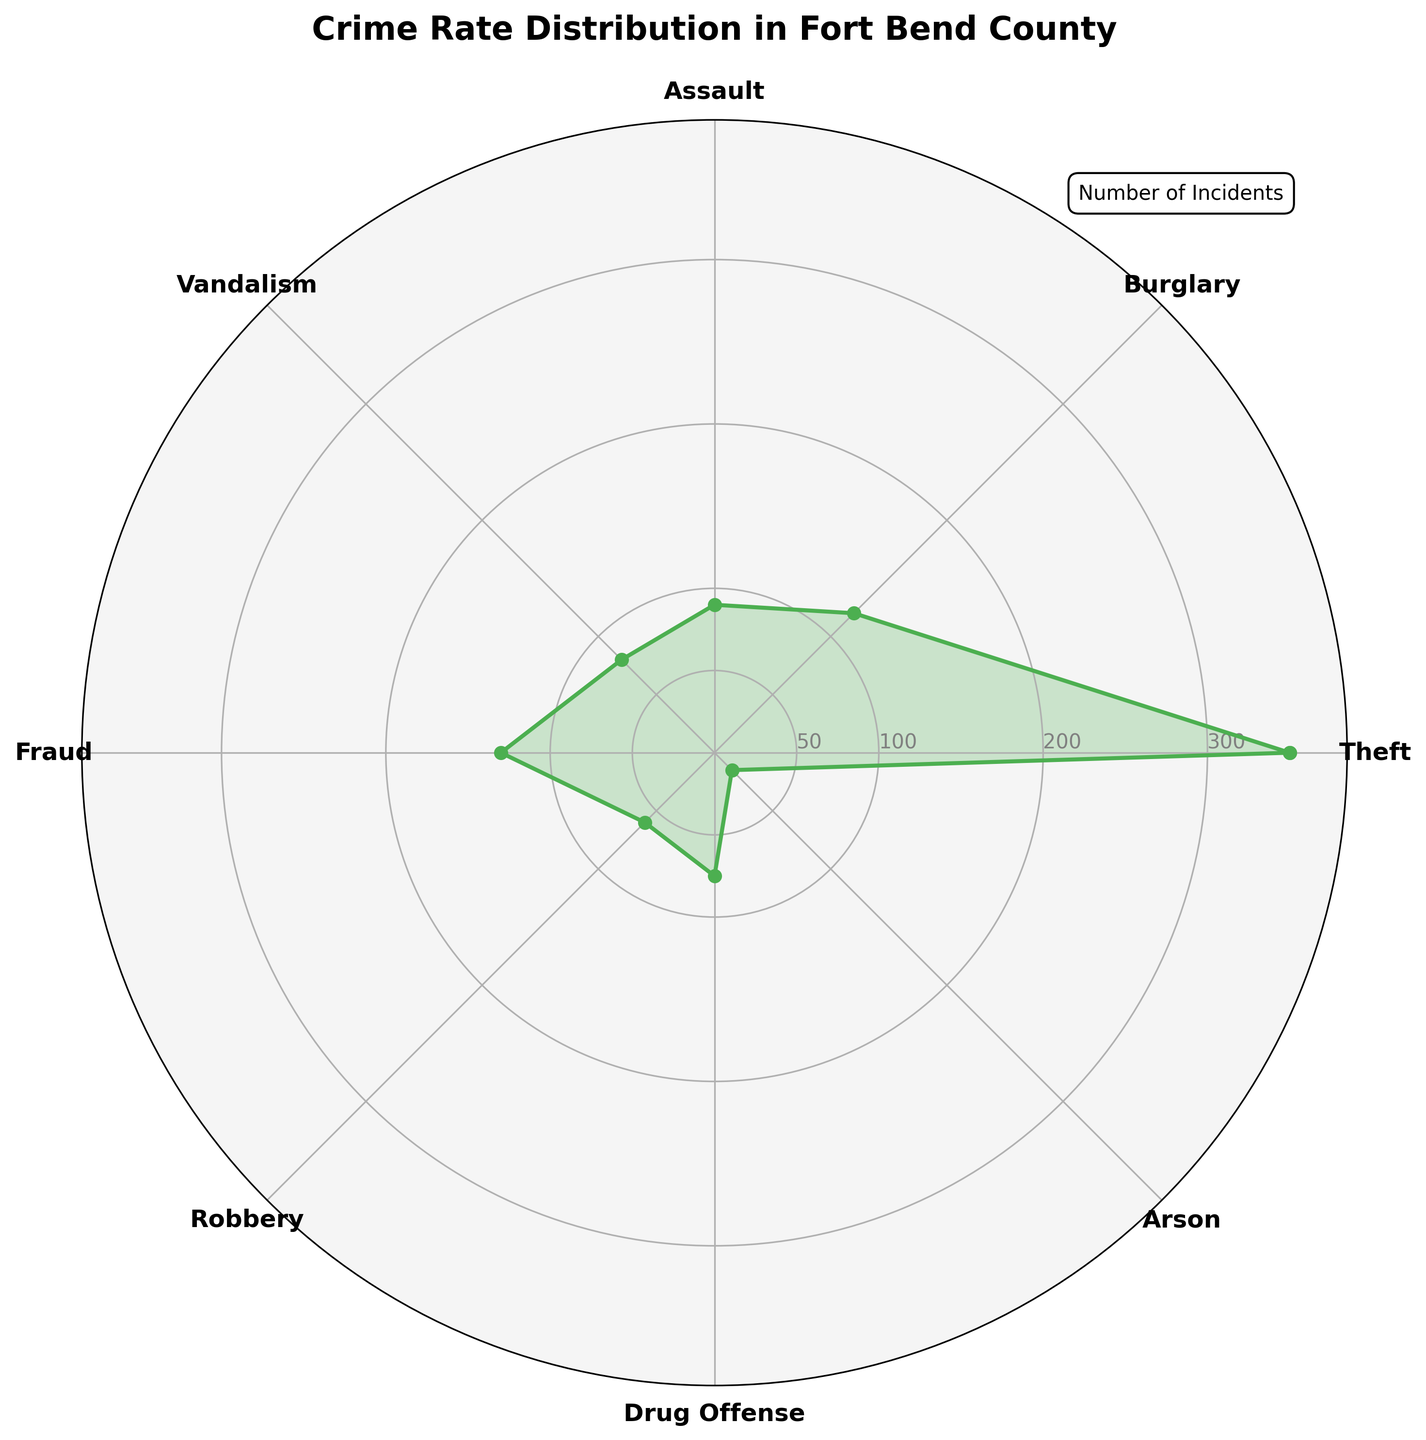what's the title of the chart? Look at the top of the chart where the title is usually placed. The font size is larger and bold. It reads "Crime Rate Distribution in Fort Bend County".
Answer: Crime Rate Distribution in Fort Bend County what color is used to plot the crime rates? Look at the lines and the filled areas representing the data. Notice the lines and fill are in a shade of green.
Answer: Green which crime type has the highest number of incidents? Observe the radar chart and find the segment that stretches the furthest from the center. This segment corresponds to Theft.
Answer: Theft how many categories of crime types are presented in the chart? Count the different labels around the circumference of the radar chart. Each label represents a crime type. There should be eight.
Answer: 8 what are the y-axis tick marks on the chart? Look at the concentric circles inside the radar chart. The tick marks are labeled at certain intervals. They are 50, 100, 200, and 300.
Answer: 50, 100, 200, 300 which crime type has the least number of incidents? Find the segment that is closest to the center. This segment corresponds to Arson.
Answer: Arson what is the difference in number of incidents between Fraud and Assault? Reference the values for Fraud (130) and Assault (90). Subtract the number of incidents for Assault from Fraud: 130 - 90 = 40.
Answer: 40 which two crime types have a number of incidents within the range of 70 to 90? Look at the segments which fall within the specified range on the chart. These segments correspond to Drug Offense (75) and Assault (90).
Answer: Drug Offense, Assault how does the number of burglary incidents compare to robbery incidents? Reference the radar chart segments for Burglary (120) and Robbery (60). Burglary incidents are greater in number compared to Robbery.
Answer: Burglary > Robbery what is the average number of incidents for Theft, Burglary, and Assault? To find the average, add the numbers for the three crime types and divide by 3. (350 + 120 + 90) / 3 = 560 / 3 = 186.67.
Answer: 186.67 